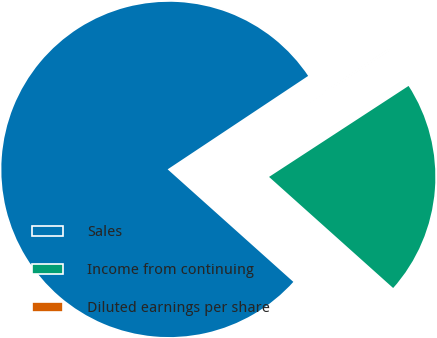Convert chart to OTSL. <chart><loc_0><loc_0><loc_500><loc_500><pie_chart><fcel>Sales<fcel>Income from continuing<fcel>Diluted earnings per share<nl><fcel>79.04%<fcel>20.82%<fcel>0.14%<nl></chart> 